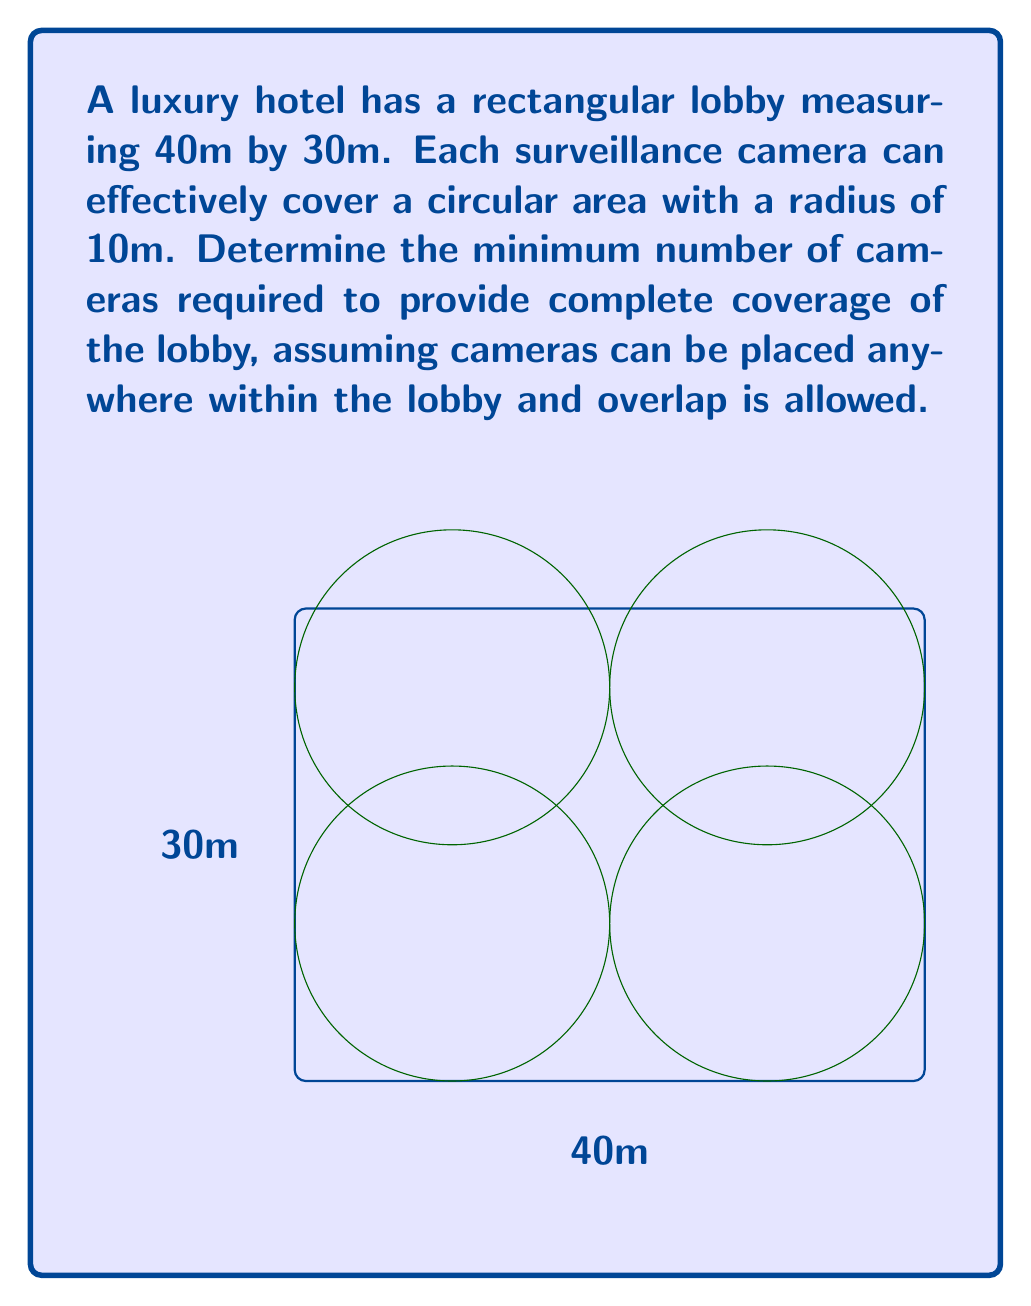Can you solve this math problem? To solve this problem, we need to follow these steps:

1) First, let's calculate the area of the lobby:
   $A_{lobby} = 40m \times 30m = 1200m^2$

2) Now, let's calculate the area that each camera can cover:
   $A_{camera} = \pi r^2 = \pi \times 10^2 = 100\pi m^2$

3) If we divide the lobby area by the camera coverage area, we get:
   $\frac{A_{lobby}}{A_{camera}} = \frac{1200}{100\pi} \approx 3.82$

4) This suggests we need at least 4 cameras. However, we need to verify if 4 cameras can indeed cover the entire area due to the rectangular shape of the lobby.

5) The optimal placement for 4 cameras would be in the corners of a rectangle, each 10m from the nearest walls. This placement is shown in the diagram.

6) With this placement, we can see that the entire lobby is covered by the four circular coverage areas.

Therefore, 4 cameras are sufficient to cover the entire lobby.
Answer: 4 cameras 